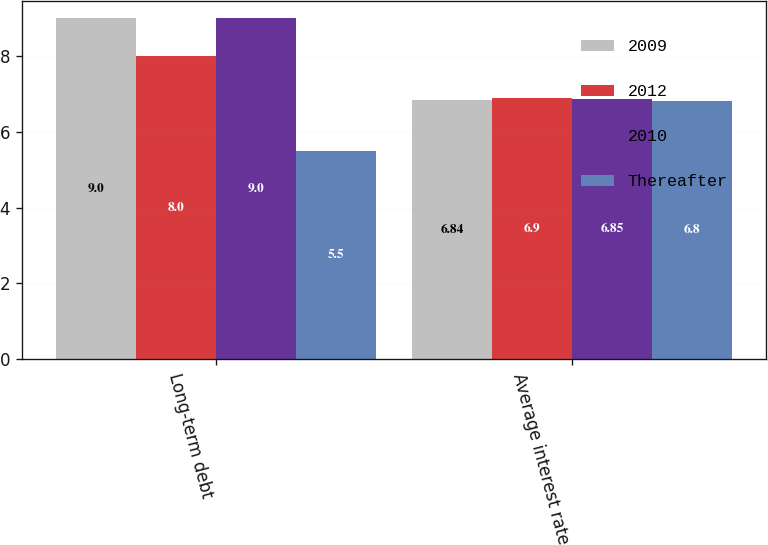Convert chart to OTSL. <chart><loc_0><loc_0><loc_500><loc_500><stacked_bar_chart><ecel><fcel>Long-term debt<fcel>Average interest rate<nl><fcel>2009<fcel>9<fcel>6.84<nl><fcel>2012<fcel>8<fcel>6.9<nl><fcel>2010<fcel>9<fcel>6.85<nl><fcel>Thereafter<fcel>5.5<fcel>6.8<nl></chart> 